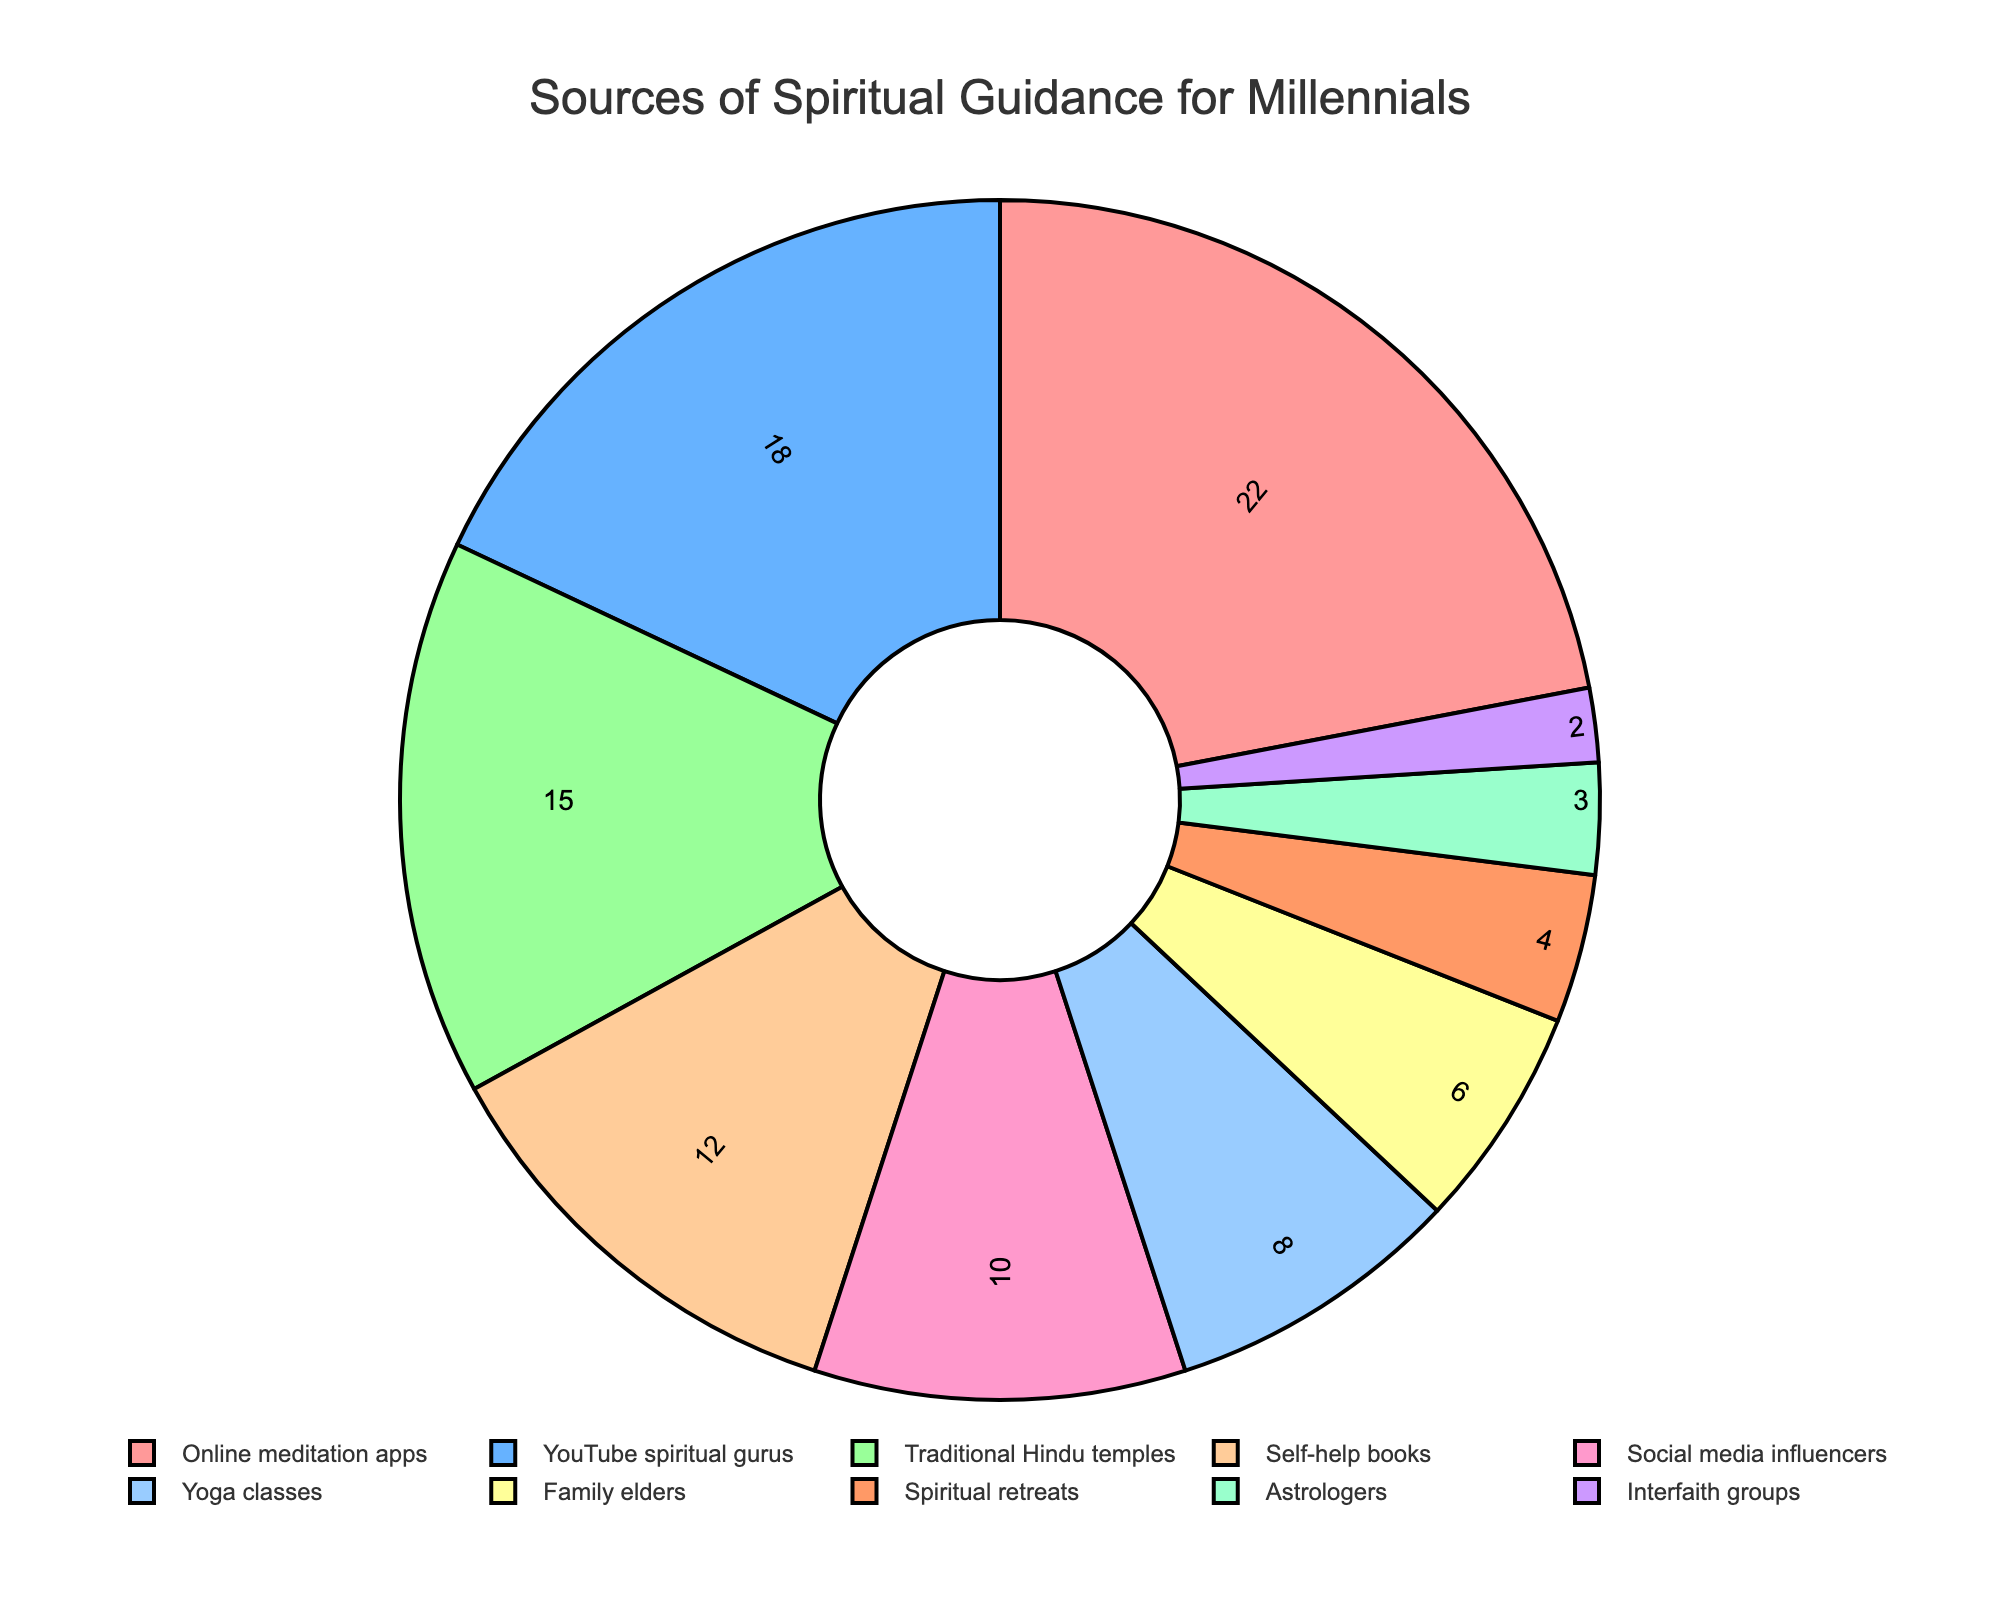What's the most common source of spiritual guidance among millennials? The figure shows that "Online meditation apps" has the highest percentage of 22%, making it the most common source.
Answer: Online meditation apps Which is more popular, YouTube spiritual gurus or Traditional Hindu temples? Compare the percentages of "YouTube spiritual gurus" (18%) and "Traditional Hindu temples" (15%). Since 18% is greater than 15%, YouTube spiritual gurus are more popular.
Answer: YouTube spiritual gurus How much more popular are Online meditation apps than Social media influencers? Subtract the percentage of "Social media influencers" (10%) from that of "Online meditation apps" (22%). The difference is 22% - 10% = 12%.
Answer: 12% What's the combined percentage of people seeking spiritual guidance from Family elders and Astrologers? Add the percentages for "Family elders" (6%) and "Astrologers" (3%). The combined percentage is 6% + 3% = 9%.
Answer: 9% Which source occupies the smallest portion in the pie chart? Identify the source with the smallest percentage, which is "Interfaith groups" with 2%.
Answer: Interfaith groups Are Spiritual retreats or Yoga classes a more common source of guidance? Compare the percentages of "Yoga classes" (8%) and "Spiritual retreats" (4%). Since 8% is greater than 4%, Yoga classes are more common.
Answer: Yoga classes Which three sources together account for over 50% of the spiritual guidance sought? Adding the percentages of "Online meditation apps" (22%), "YouTube spiritual gurus" (18%), and "Traditional Hindu temples" (15%) gives 22% + 18% + 15% = 55%. The total is over 50%.
Answer: Online meditation apps, YouTube spiritual gurus, Traditional Hindu temples Which color represents Social media influencers? In the pie chart, Social media influencers are represented by the color that is fifth from the top, which is a shade of blue.
Answer: Blue What's the visual orientation of text information inside the slices of the pie chart? The figure shows that the text inside the slices is oriented radially.
Answer: Radial 